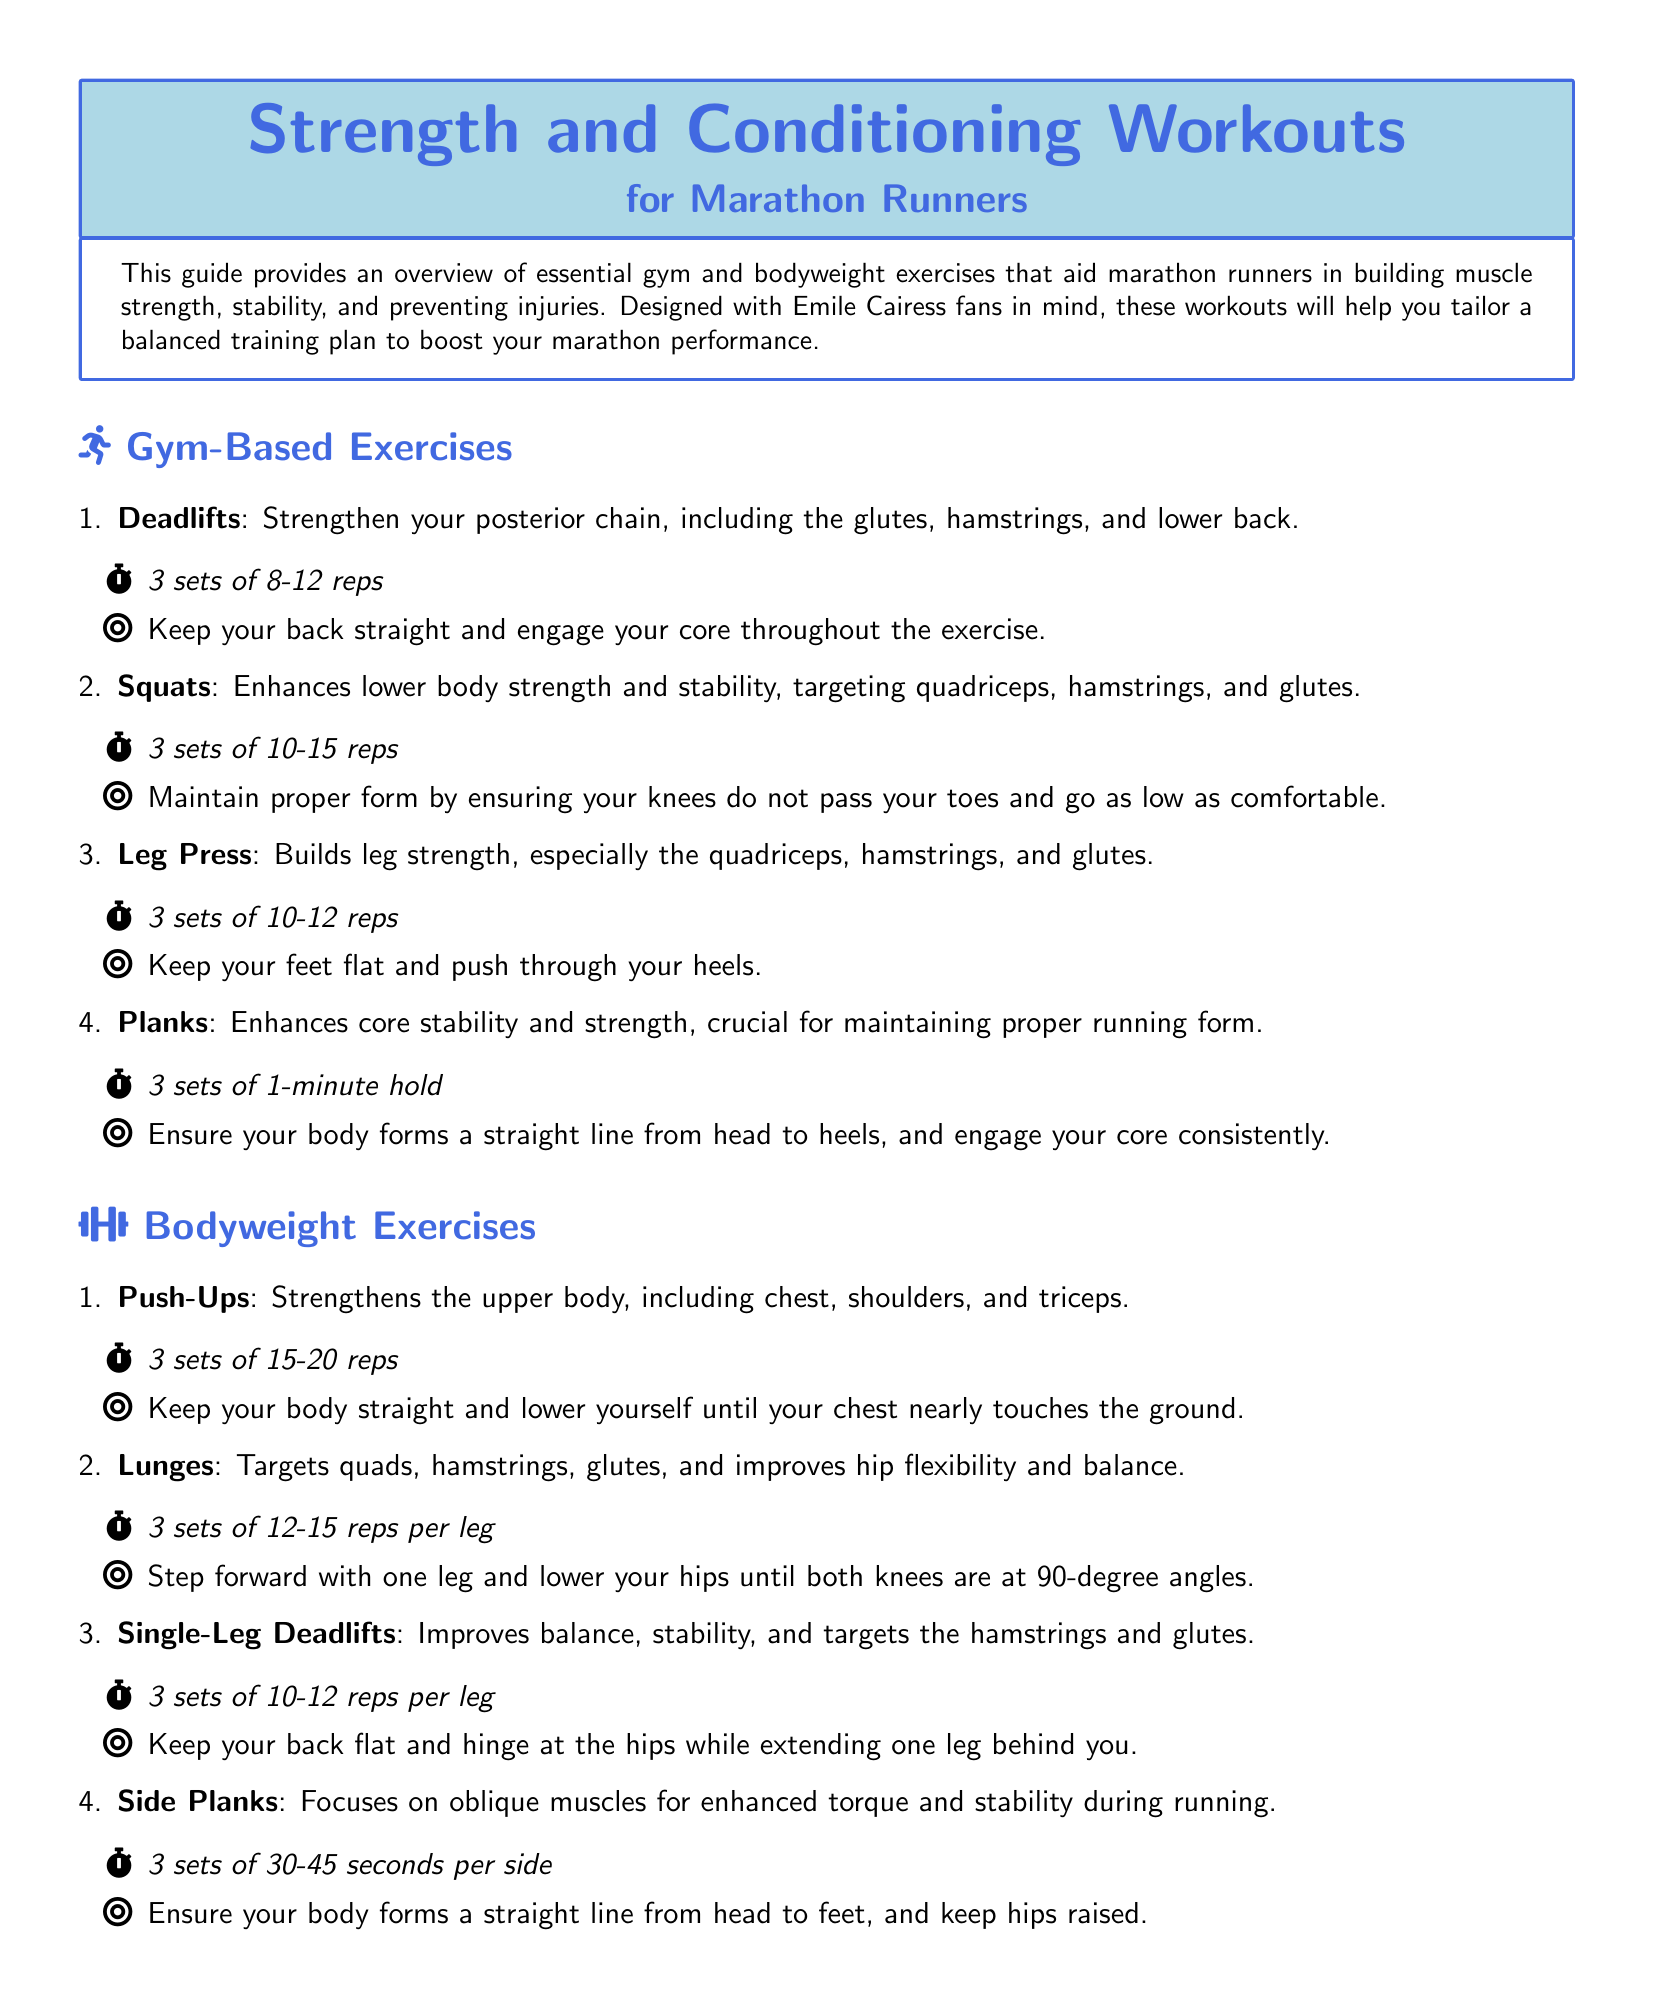What is the main focus of the workout plan? The document emphasizes building muscle strength, stability, and injury prevention for marathon runners.
Answer: Strength and conditioning How many sets of deadlifts are recommended? The document specifies the number of sets for deadlifts in the gym-based exercises section.
Answer: 3 sets What exercise targets the upper body muscles? The document lists exercises and specifies their targeted muscles, particularly in the bodyweight exercises section.
Answer: Push-Ups What is the duration for holding planks? The document provides specific instructions for the duration of various exercises, including planks.
Answer: 1-minute hold Which exercise is recommended for improving hip flexibility? The document highlights exercises that promote flexibility and their specific benefits.
Answer: Lunges How long should dynamic stretches be performed? The document outlines the duration for performing various warm-up exercises, including dynamic stretches.
Answer: 5-10 minutes What type of recovery method is foam rolling categorized as? The document classifies exercises under injury prevention and recovery categories and details their purposes.
Answer: Self-myofascial release How many reps are suggested for single-leg deadlifts? The document provides the recommended repetitions for various exercises, including single-leg deadlifts.
Answer: 10-12 reps per leg 